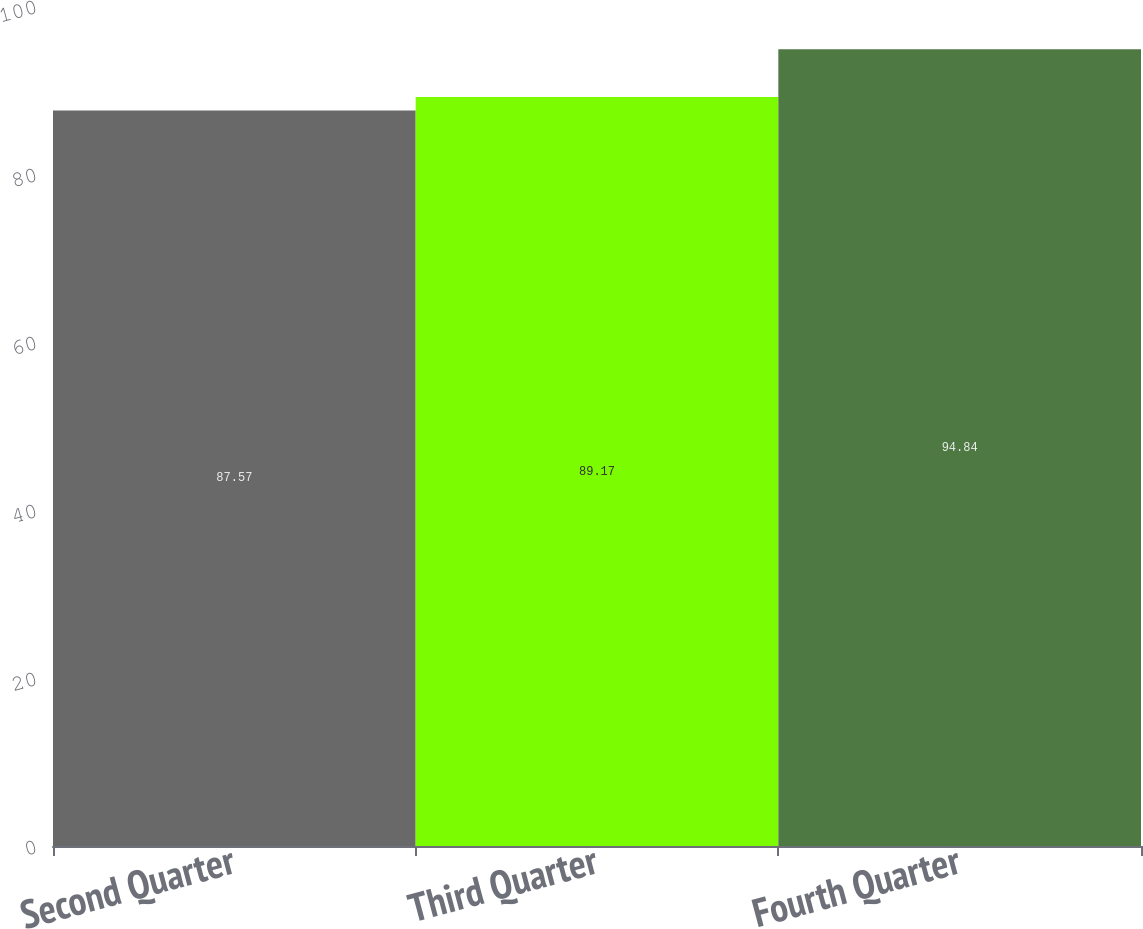Convert chart. <chart><loc_0><loc_0><loc_500><loc_500><bar_chart><fcel>Second Quarter<fcel>Third Quarter<fcel>Fourth Quarter<nl><fcel>87.57<fcel>89.17<fcel>94.84<nl></chart> 